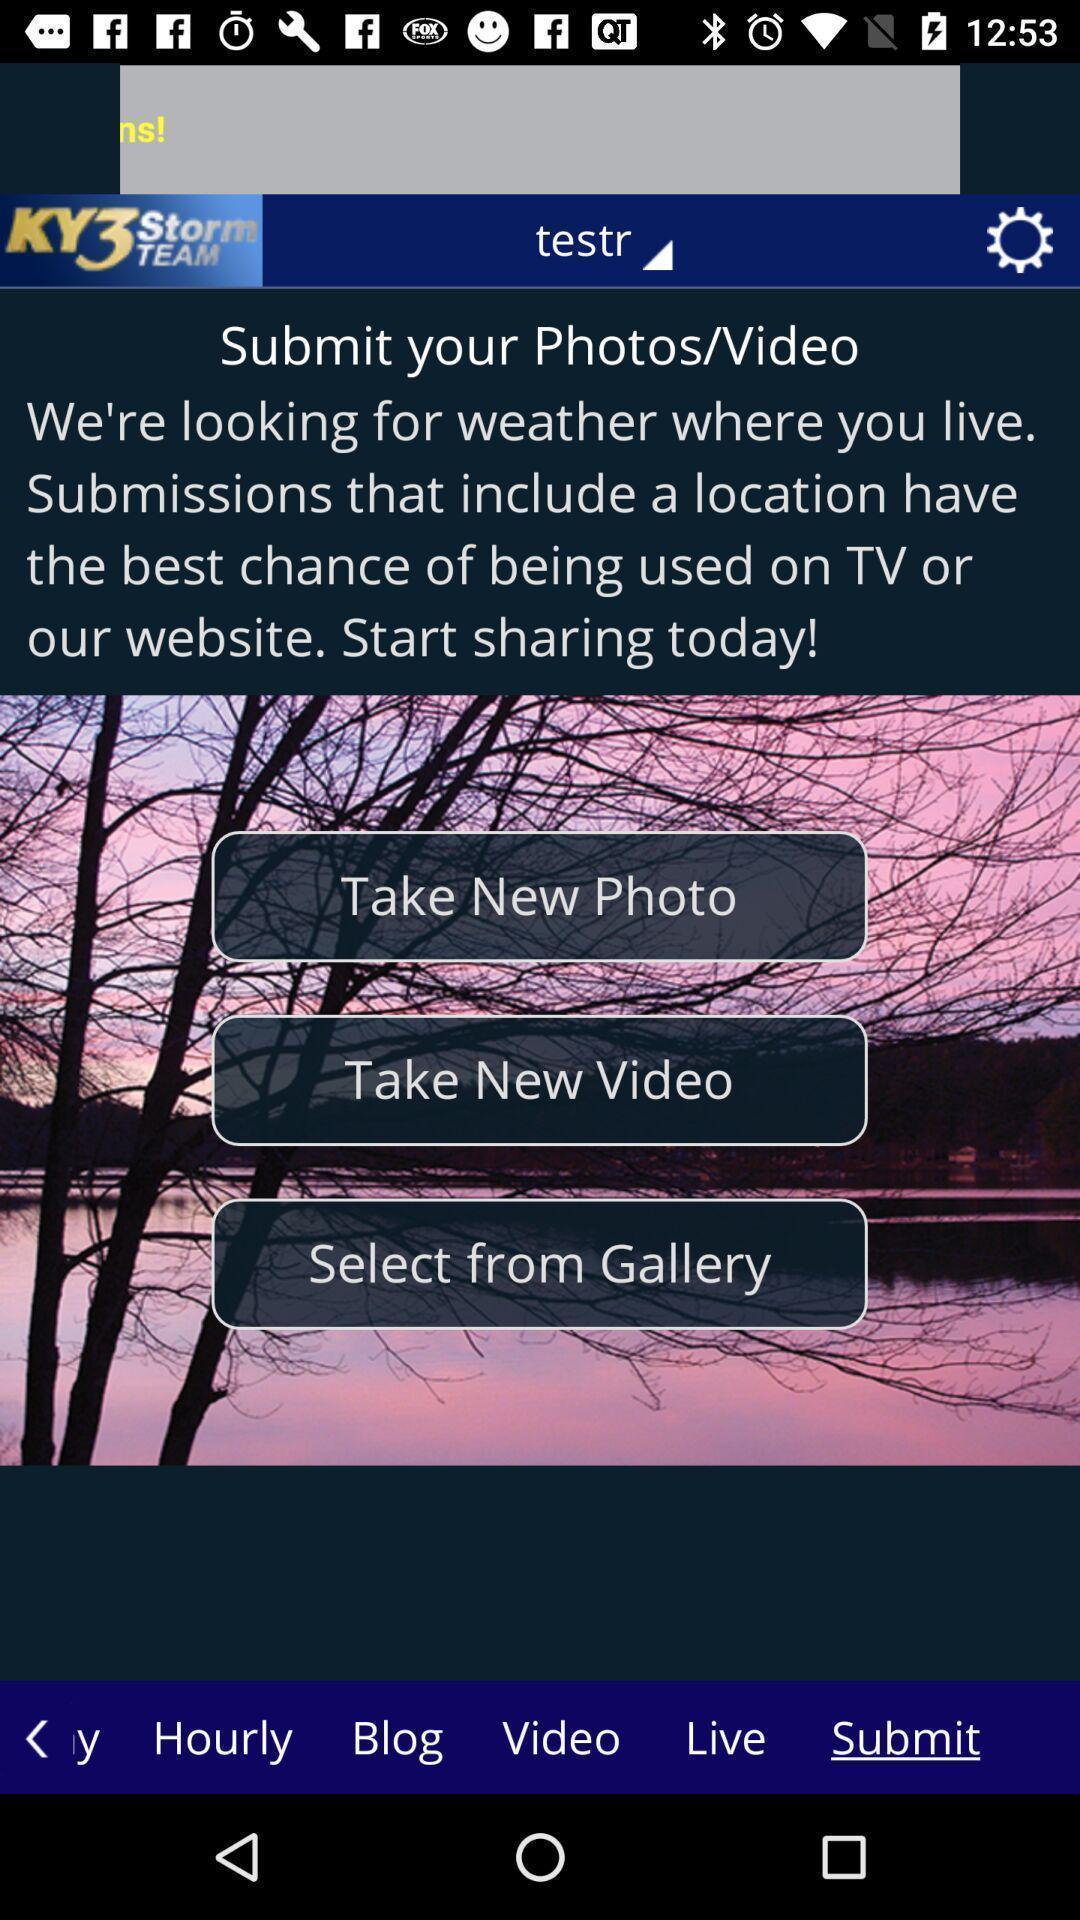Explain what's happening in this screen capture. Page of takings pics videos for checking weather. 